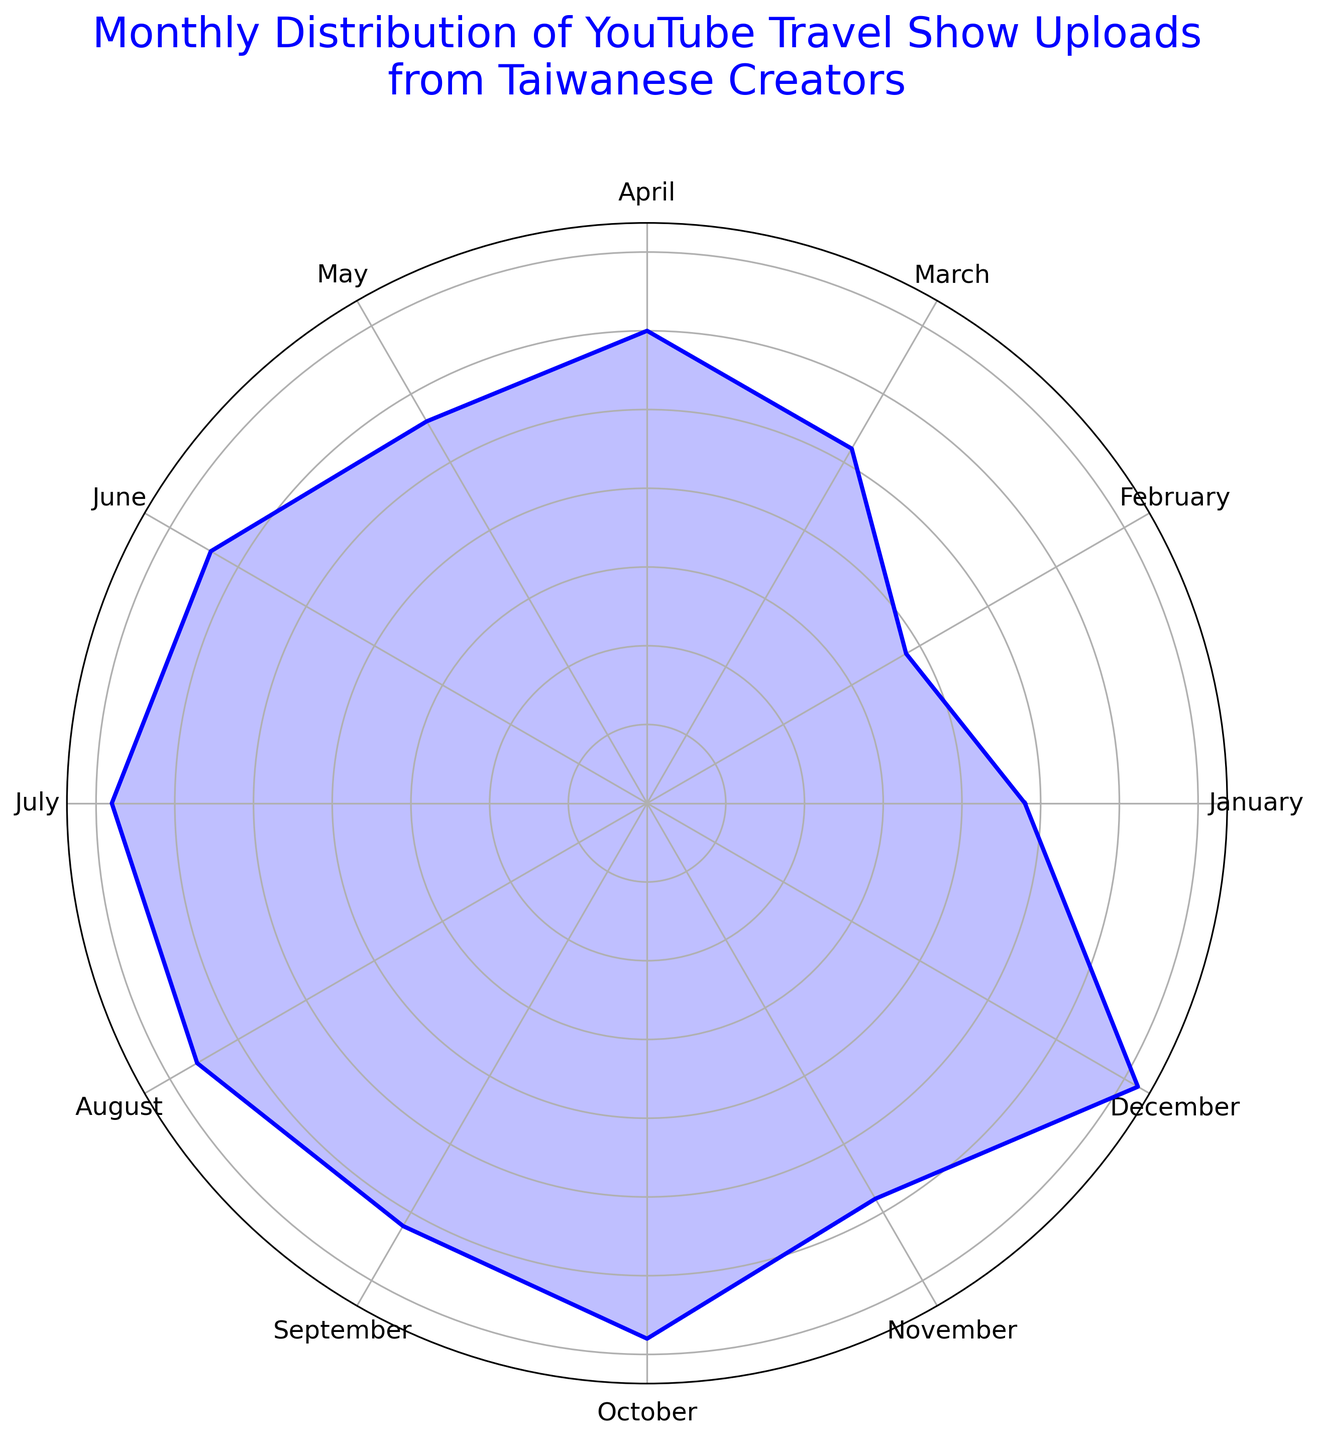What month has the highest number of uploads? By looking at the outer edge of the rose chart, where the length of the plotted line is longest, we can see which month corresponds to the highest point. December has the longest line, indicating it has the most uploads.
Answer: December Which month has fewer uploads, February or July? We observe the lengths of the plotted lines for February and July. February's point is closer to the center compared to July's, indicating fewer uploads.
Answer: February What is the difference in the number of uploads between June and March? By noting the respective lengths of the plotted lines for June and March, June is longer. June has 160 uploads and March has 130 uploads; the difference is 160 - 130.
Answer: 30 Compare the uploads in April with those in September. Which month has more, and by how much? Observing the lengths of the plotted lines for April and September, April's line is longer. April has 150 uploads, and September has 155. The difference is 155 - 150.
Answer: September by 5 Which three consecutive months have the highest average uploads? By visually identifying which consecutive months have long line lengths, we estimate. Focusing on the lines for October, November, and December, October has 170, November 145, and December 180. The average is (170 + 145 + 180)/3 = 495/3.
Answer: October, November, December; 165 In which month did the upload count exceed 160 but did not exceed 170? Observing the radial lengths, we note that August's line is between 160 and 170. The upload count for August is 165.
Answer: August Identify two months where the number of uploads is the same. Noting the identical radial lengths, July and October both have the same length, meaning they have the same number of uploads. Both months have 170 uploads.
Answer: July and October What is the total number of uploads from March to June? Adding the uploads from March to June: March (130) + April (150) + May (140) + June (160). The sum is 130 + 150 + 140 + 160 = 580.
Answer: 580 Is there any month with fewer uploads than January? If yes, name one. Comparing the lengths of the line from the center for January against other months, February’s line is shorter.
Answer: February Which month has the closest number of uploads to the annual average? Calculate the average first: sum of all uploads divided by 12. Sum = 180 + 170 + 145 + 170 + 155 + 165 + 170 + 160 + 140 + 150 + 130 + 95 + 120 = 1870. The average is 1870/12 ≈ 155. The month closest to 155 is September with 155 uploads.
Answer: September 